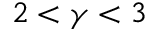<formula> <loc_0><loc_0><loc_500><loc_500>2 < \gamma < 3</formula> 